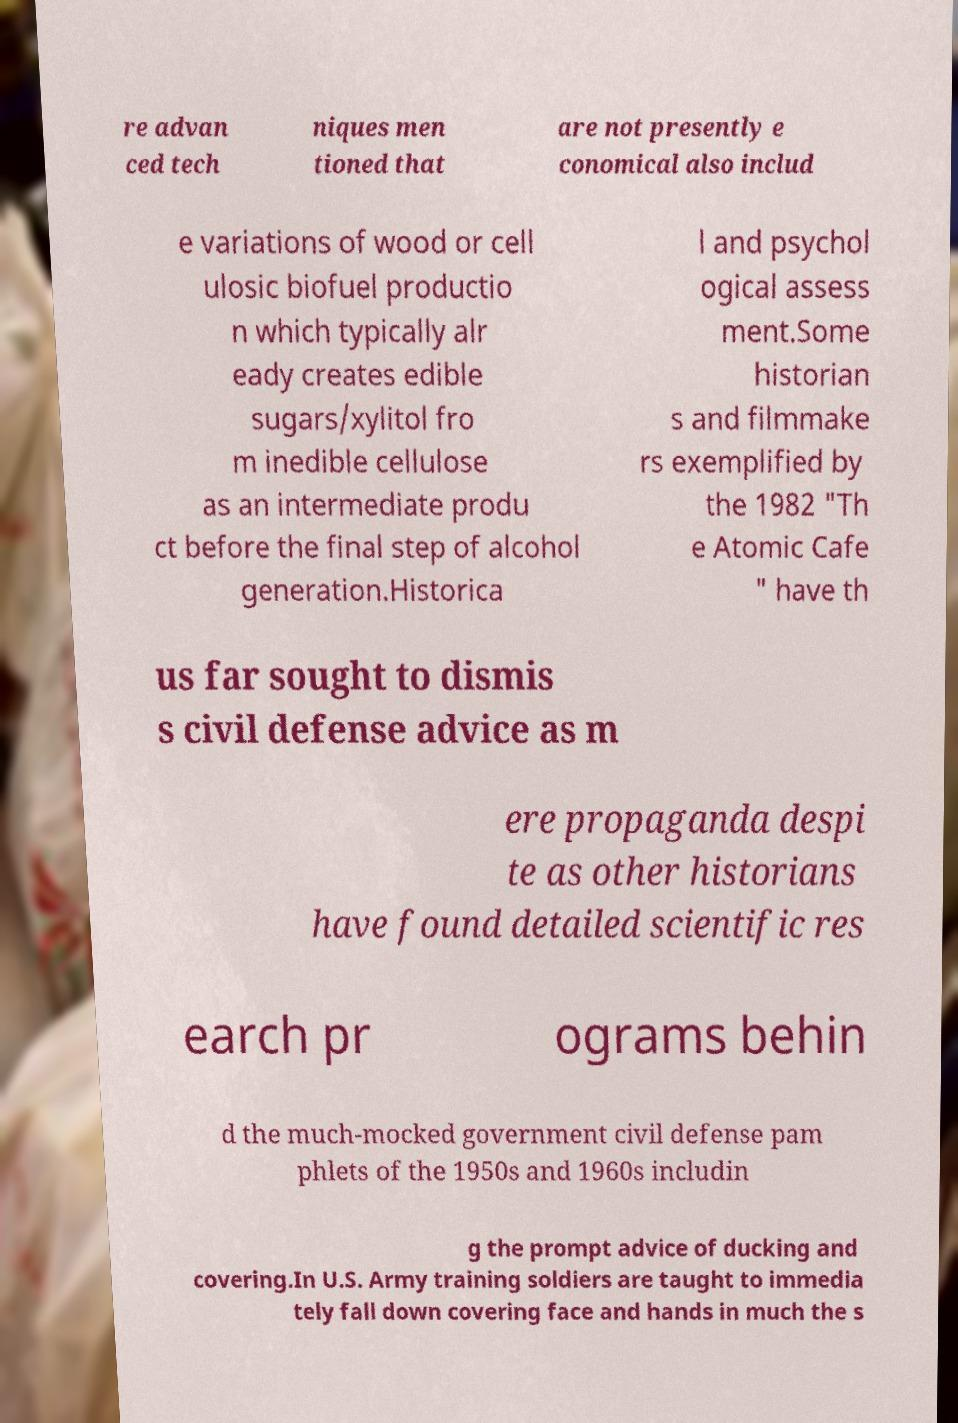Please identify and transcribe the text found in this image. re advan ced tech niques men tioned that are not presently e conomical also includ e variations of wood or cell ulosic biofuel productio n which typically alr eady creates edible sugars/xylitol fro m inedible cellulose as an intermediate produ ct before the final step of alcohol generation.Historica l and psychol ogical assess ment.Some historian s and filmmake rs exemplified by the 1982 "Th e Atomic Cafe " have th us far sought to dismis s civil defense advice as m ere propaganda despi te as other historians have found detailed scientific res earch pr ograms behin d the much-mocked government civil defense pam phlets of the 1950s and 1960s includin g the prompt advice of ducking and covering.In U.S. Army training soldiers are taught to immedia tely fall down covering face and hands in much the s 